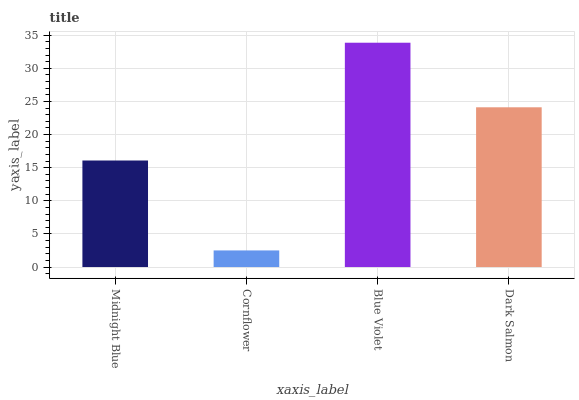Is Cornflower the minimum?
Answer yes or no. Yes. Is Blue Violet the maximum?
Answer yes or no. Yes. Is Blue Violet the minimum?
Answer yes or no. No. Is Cornflower the maximum?
Answer yes or no. No. Is Blue Violet greater than Cornflower?
Answer yes or no. Yes. Is Cornflower less than Blue Violet?
Answer yes or no. Yes. Is Cornflower greater than Blue Violet?
Answer yes or no. No. Is Blue Violet less than Cornflower?
Answer yes or no. No. Is Dark Salmon the high median?
Answer yes or no. Yes. Is Midnight Blue the low median?
Answer yes or no. Yes. Is Midnight Blue the high median?
Answer yes or no. No. Is Cornflower the low median?
Answer yes or no. No. 